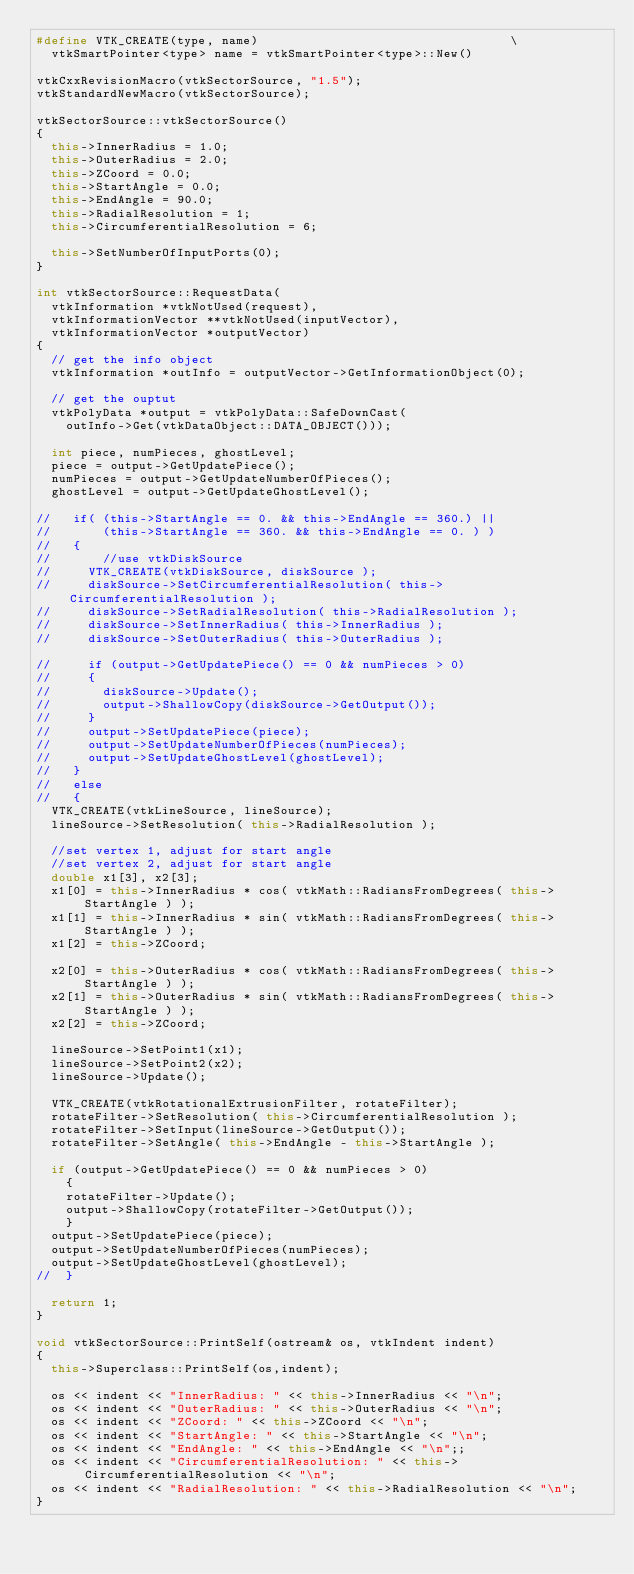Convert code to text. <code><loc_0><loc_0><loc_500><loc_500><_C++_>#define VTK_CREATE(type, name)                                  \
  vtkSmartPointer<type> name = vtkSmartPointer<type>::New()

vtkCxxRevisionMacro(vtkSectorSource, "1.5");
vtkStandardNewMacro(vtkSectorSource);

vtkSectorSource::vtkSectorSource()
{
  this->InnerRadius = 1.0;
  this->OuterRadius = 2.0;
  this->ZCoord = 0.0;
  this->StartAngle = 0.0;
  this->EndAngle = 90.0;
  this->RadialResolution = 1;
  this->CircumferentialResolution = 6;
  
  this->SetNumberOfInputPorts(0);
}

int vtkSectorSource::RequestData(
  vtkInformation *vtkNotUsed(request),
  vtkInformationVector **vtkNotUsed(inputVector),
  vtkInformationVector *outputVector)
{
  // get the info object
  vtkInformation *outInfo = outputVector->GetInformationObject(0);
  
  // get the ouptut
  vtkPolyData *output = vtkPolyData::SafeDownCast(
    outInfo->Get(vtkDataObject::DATA_OBJECT()));
  
  int piece, numPieces, ghostLevel;
  piece = output->GetUpdatePiece();
  numPieces = output->GetUpdateNumberOfPieces();
  ghostLevel = output->GetUpdateGhostLevel();
  
//   if( (this->StartAngle == 0. && this->EndAngle == 360.) ||
//       (this->StartAngle == 360. && this->EndAngle == 0. ) )
//   {
//       //use vtkDiskSource
//     VTK_CREATE(vtkDiskSource, diskSource );
//     diskSource->SetCircumferentialResolution( this->CircumferentialResolution );
//     diskSource->SetRadialResolution( this->RadialResolution );
//     diskSource->SetInnerRadius( this->InnerRadius );
//     diskSource->SetOuterRadius( this->OuterRadius );
  
//     if (output->GetUpdatePiece() == 0 && numPieces > 0)
//     {
//       diskSource->Update();
//       output->ShallowCopy(diskSource->GetOutput());
//     }
//     output->SetUpdatePiece(piece);
//     output->SetUpdateNumberOfPieces(numPieces);
//     output->SetUpdateGhostLevel(ghostLevel);
//   }
//   else
//   {
  VTK_CREATE(vtkLineSource, lineSource);
  lineSource->SetResolution( this->RadialResolution );
  
  //set vertex 1, adjust for start angle
  //set vertex 2, adjust for start angle
  double x1[3], x2[3];
  x1[0] = this->InnerRadius * cos( vtkMath::RadiansFromDegrees( this->StartAngle ) );
  x1[1] = this->InnerRadius * sin( vtkMath::RadiansFromDegrees( this->StartAngle ) );
  x1[2] = this->ZCoord;
  
  x2[0] = this->OuterRadius * cos( vtkMath::RadiansFromDegrees( this->StartAngle ) );
  x2[1] = this->OuterRadius * sin( vtkMath::RadiansFromDegrees( this->StartAngle ) );
  x2[2] = this->ZCoord;
  
  lineSource->SetPoint1(x1);
  lineSource->SetPoint2(x2);
  lineSource->Update();
  
  VTK_CREATE(vtkRotationalExtrusionFilter, rotateFilter);
  rotateFilter->SetResolution( this->CircumferentialResolution );
  rotateFilter->SetInput(lineSource->GetOutput());
  rotateFilter->SetAngle( this->EndAngle - this->StartAngle );
  
  if (output->GetUpdatePiece() == 0 && numPieces > 0)
    {
    rotateFilter->Update();
    output->ShallowCopy(rotateFilter->GetOutput());
    }
  output->SetUpdatePiece(piece);
  output->SetUpdateNumberOfPieces(numPieces);
  output->SetUpdateGhostLevel(ghostLevel);
//  }
  
  return 1;
}

void vtkSectorSource::PrintSelf(ostream& os, vtkIndent indent)
{
  this->Superclass::PrintSelf(os,indent);
  
  os << indent << "InnerRadius: " << this->InnerRadius << "\n";
  os << indent << "OuterRadius: " << this->OuterRadius << "\n";
  os << indent << "ZCoord: " << this->ZCoord << "\n";
  os << indent << "StartAngle: " << this->StartAngle << "\n";
  os << indent << "EndAngle: " << this->EndAngle << "\n";;
  os << indent << "CircumferentialResolution: " << this->CircumferentialResolution << "\n";
  os << indent << "RadialResolution: " << this->RadialResolution << "\n";
}
</code> 